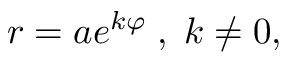Convert formula to latex. <formula><loc_0><loc_0><loc_500><loc_500>\, r = a e ^ { k \varphi } \, , \, k \neq 0 ,</formula> 